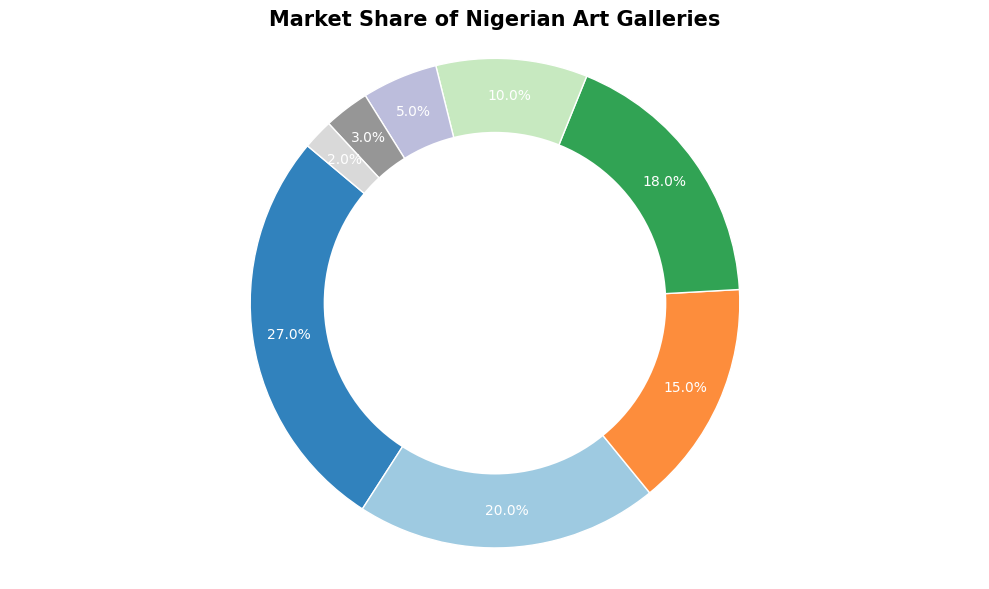Which gallery has the largest market share? From the figure, we observe that the Nike Art Gallery occupies the largest section of the pie chart.
Answer: Nike Art Gallery Which gallery has the smallest market share? From the figure, we observe that the Signature Beyond Gallery occupies the smallest section of the pie chart.
Answer: Signature Beyond Gallery What is the combined market share of Nike Art Gallery and Omenka Gallery? The figure shows Nike Art Gallery with a market share of 27% and Omenka Gallery with 20%. Adding these two values gives: 27% + 20% = 47%.
Answer: 47% Which galleries together hold more than 30% of the market share? Nike Art Gallery alone holds 27%, which is less than 30%. However, combining Nike Art Gallery (27%) with any other gallery, for example, Omenka Gallery (20%), results in 27% + 20% = 47%, which is more than 30%. Hence, Nike Art Gallery and Omenka Gallery together hold more than 30%.
Answer: Nike Art Gallery and Omenka Gallery Which two art galleries have the same color wedge in the figure? Observing the visual representation of the pie chart, no two galleries share the exact same color wedge since the colors are distinct for each slice.
Answer: None What is the difference in market share between Art Twenty One and Terra Kulture? From the figure, Art Twenty One has a market share of 15% and Terra Kulture has 18%. The difference is: 18% - 15% = 3%.
Answer: 3% What percentage of the market share is held by Rele Gallery and Thought Pyramid Art Centre combined? Rele Gallery holds a market share of 5% and Thought Pyramid Art Centre holds 3%. Adding these percentages gives: 5% + 3% = 8%.
Answer: 8% Which gallery’s market share is closest to 10%? From the figure, the National Museum Lagos has a market share of exactly 10%.
Answer: National Museum Lagos By how much does the market share of Terra Kulture exceed that of National Museum Lagos? Terra Kulture has a market share of 18%, while the National Museum Lagos has 10%. Therefore, the excess is: 18% - 10% = 8%.
Answer: 8% If the market share of Nike Art Gallery increased by 5%, what would its new market share be? Currently, Nike Art Gallery has a market share of 27%. Adding 5% to this gives: 27% + 5% = 32%.
Answer: 32% 